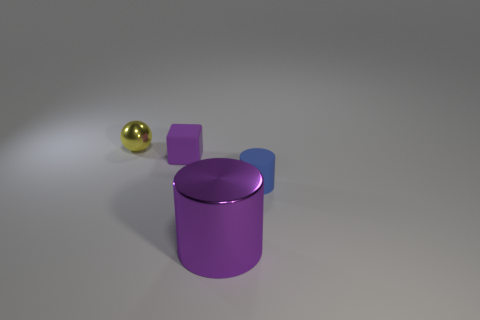Is the shape of the purple object behind the small matte cylinder the same as  the blue thing?
Keep it short and to the point. No. What is the material of the block?
Your answer should be very brief. Rubber. There is a tiny rubber thing that is to the left of the object that is in front of the cylinder behind the big thing; what is its shape?
Offer a terse response. Cube. What number of other objects are the same shape as the small blue thing?
Your answer should be compact. 1. There is a large cylinder; is it the same color as the cylinder right of the big cylinder?
Your answer should be compact. No. What number of tiny gray things are there?
Give a very brief answer. 0. What number of things are tiny yellow metal objects or large green rubber things?
Make the answer very short. 1. There is a rubber thing that is the same color as the large metal object; what is its size?
Provide a short and direct response. Small. There is a matte cylinder; are there any things right of it?
Your answer should be compact. No. Is the number of small blue rubber things that are to the right of the large purple object greater than the number of objects that are behind the block?
Your answer should be very brief. No. 